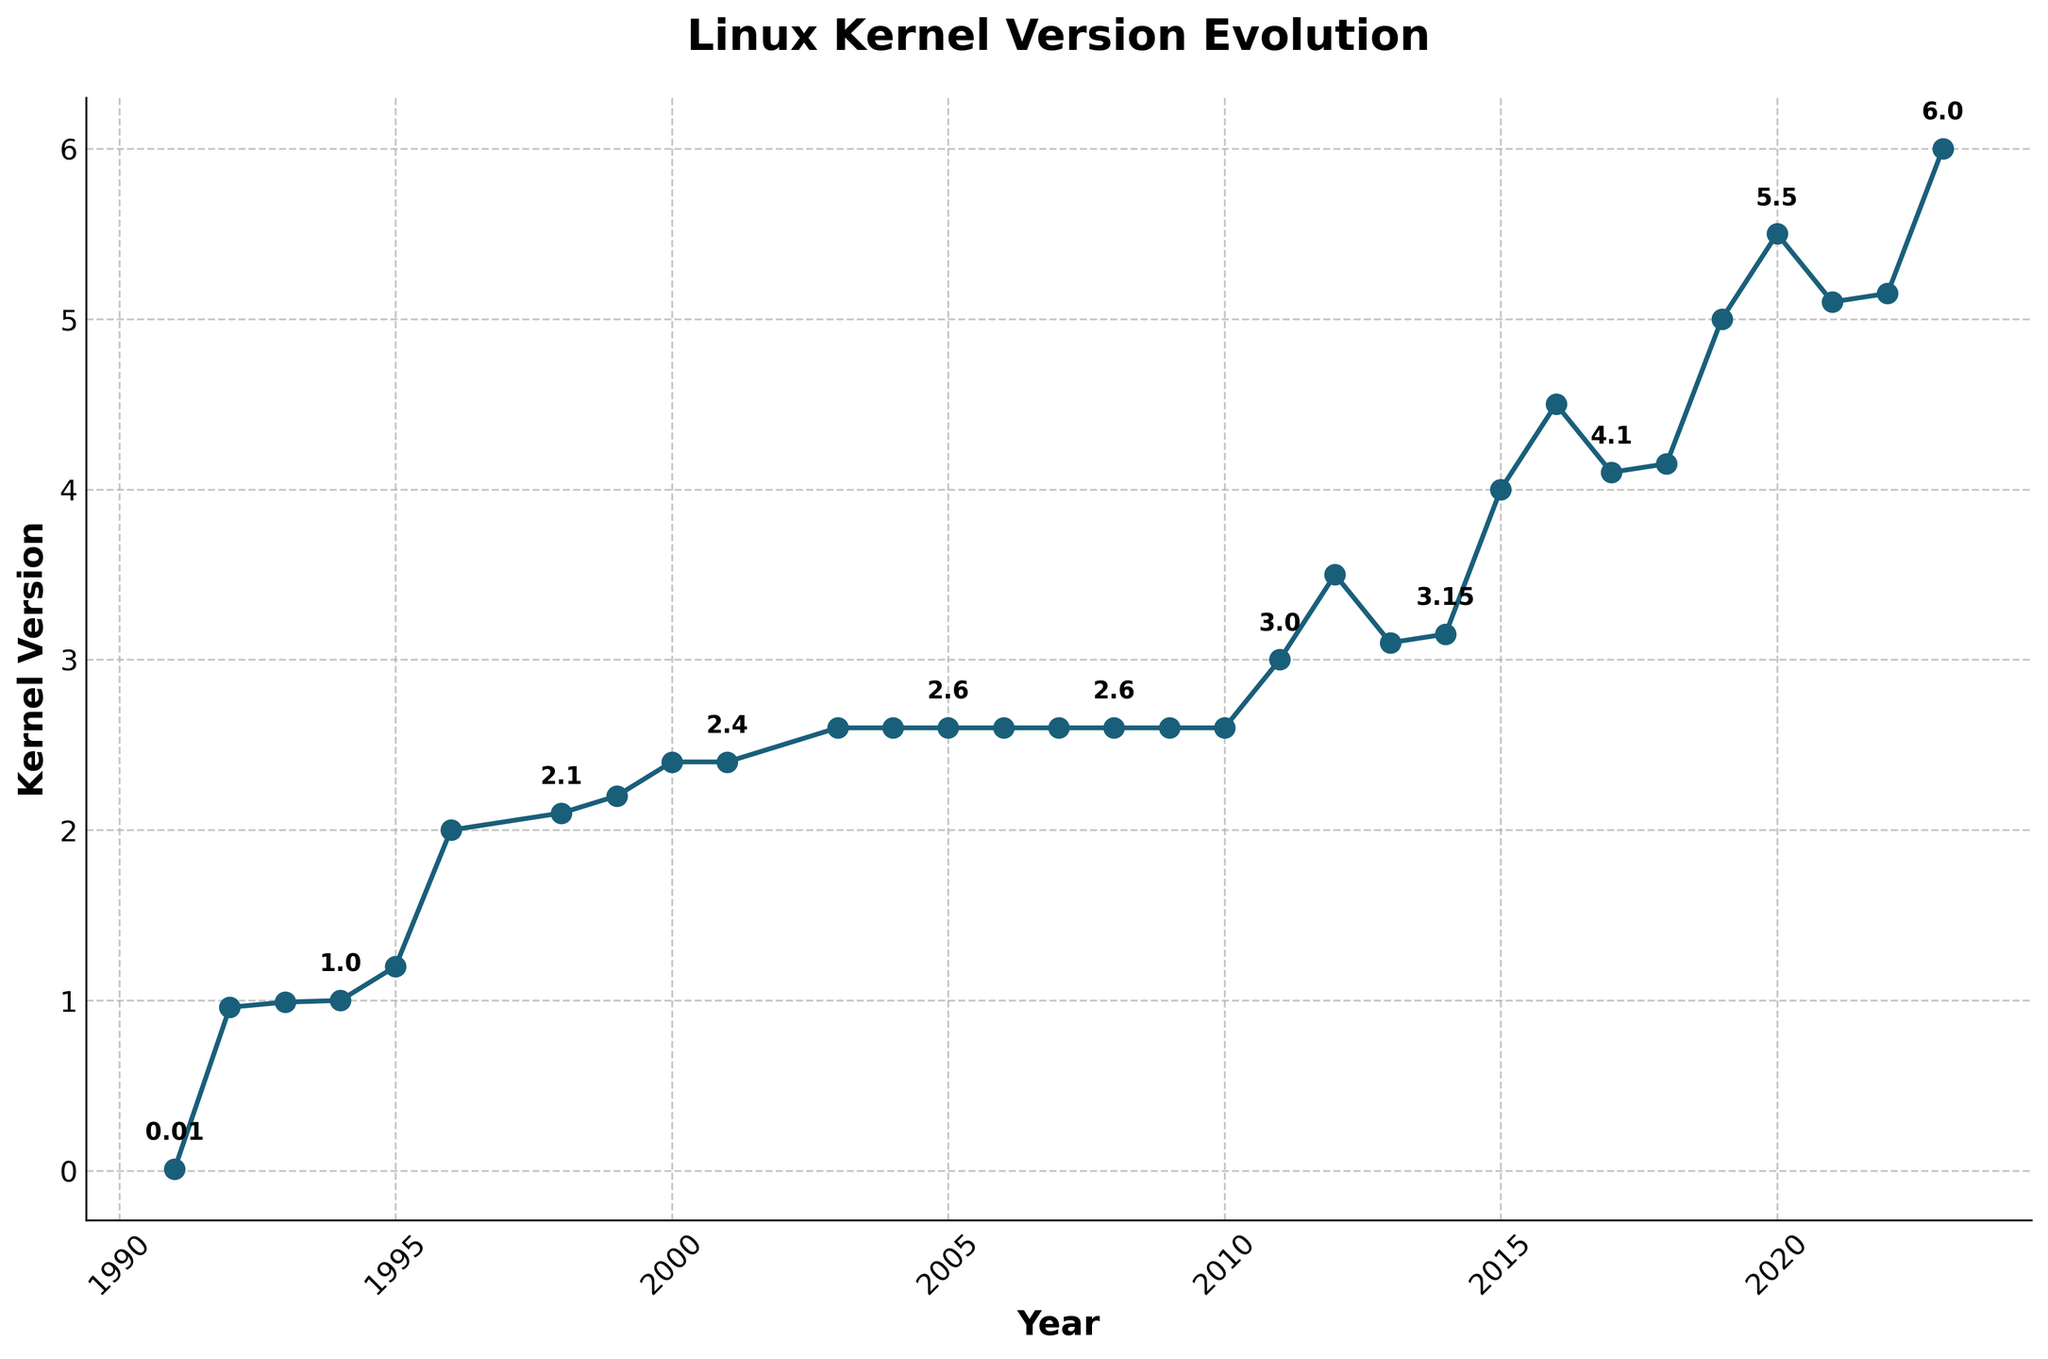What was the kernel version in 2007? Locate the year 2007 on the x-axis and trace it upward until you hit the line. The corresponding y-coordinate (kernel version) for 2007 is visible as a point with the annotation nearby.
Answer: 2.6.25 How many versions were released between 2008 and 2010, inclusive? Count the number of points plotted between 2008 and 2010 on the x-axis. Each point represents a version release.
Answer: 3 What is the difference in the kernel version between 1994 and 1996? Identify the y-coordinates for the years 1994 and 1996. The kernel version for 1994 is 1.0, and for 1996, it is 2.0. Subtract 1.0 from 2.0 to find the difference.
Answer: 1.0 Is the rate of version increase faster between 2011-2015 or 2015-2020? Compare the slopes of the line segments between 2011-2015 and 2015-2020. A steeper slope indicates a faster rate of version increase.
Answer: 2011-2015 What is the color of the line representing the kernel versions? Observe the color of the line plotted in the figure, which typically would be noted in the legend or visual appearance.
Answer: Blue What was the kernel version in the year when version 3.0 was released? Identify the year when the version 3.0 label is present on the plot. The year corresponding to version 3.0 is displayed on the x-axis.
Answer: 2011 Did the kernel version increase steadily over the years? Analyze the plot for the presence of ups, downs, or flat lines. If the version increases consistently without any decrease or plateau, it is steady.
Answer: Yes What's the average kernel version between 2000 and 2009? Calculate versions for the years 2000 (2.4), 2001 (2.4.15), 2003 (2.6), 2004 (2.6.10), 2005 (2.6.15), 2006 (2.6.20), 2007 (2.6.25), 2008 (2.6.30), and 2009 (2.6.35), sum them up and divide by the number of years.
Answer: 2.64 